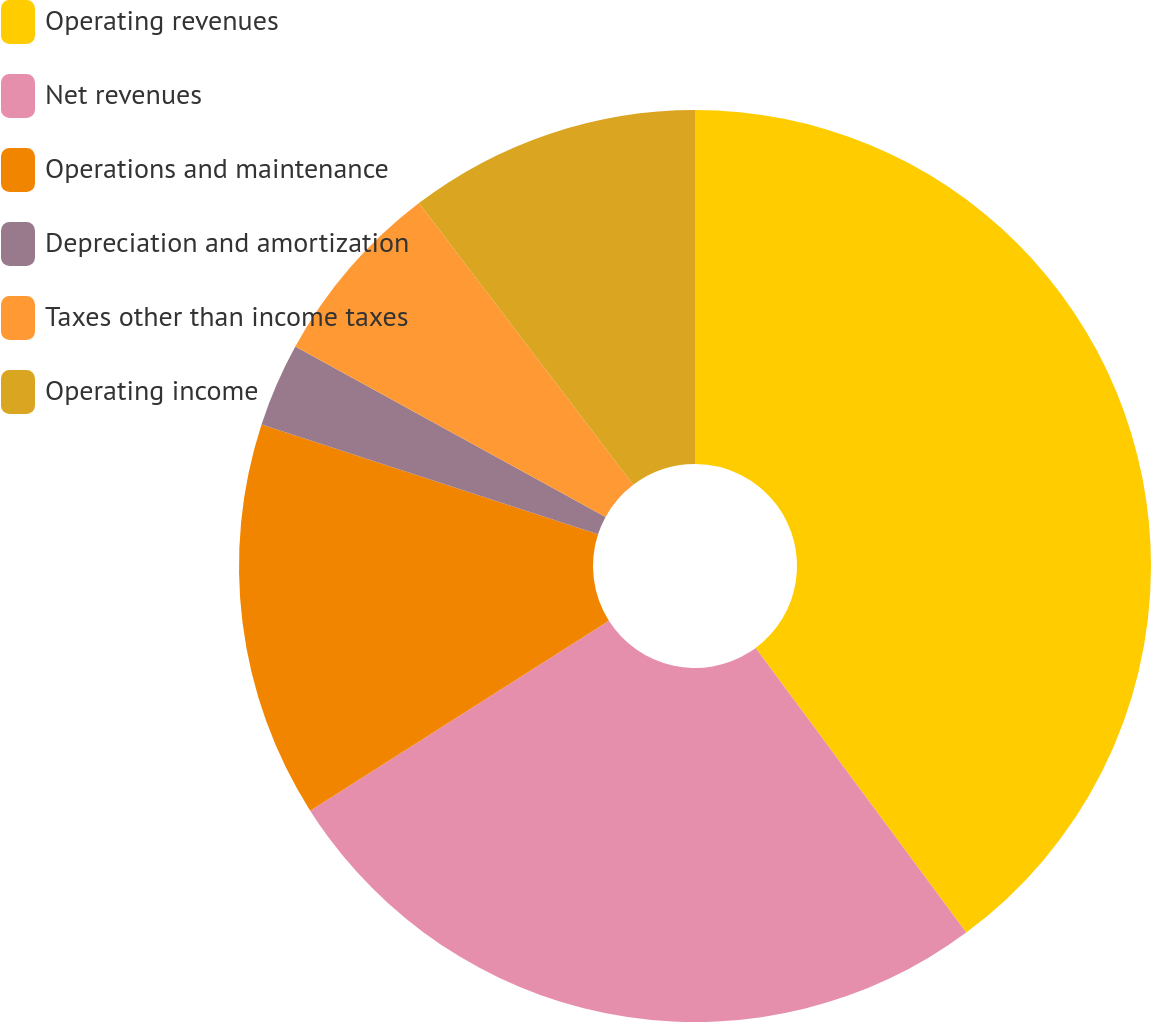Convert chart to OTSL. <chart><loc_0><loc_0><loc_500><loc_500><pie_chart><fcel>Operating revenues<fcel>Net revenues<fcel>Operations and maintenance<fcel>Depreciation and amortization<fcel>Taxes other than income taxes<fcel>Operating income<nl><fcel>39.87%<fcel>26.13%<fcel>14.04%<fcel>2.97%<fcel>6.66%<fcel>10.35%<nl></chart> 